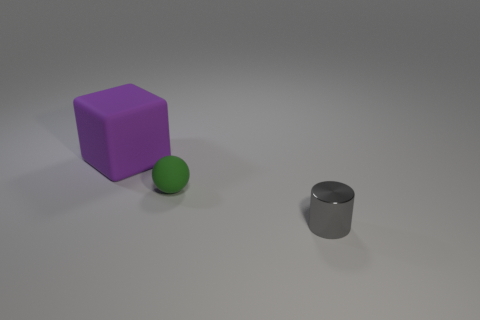Are the object that is left of the matte sphere and the tiny object that is left of the gray cylinder made of the same material?
Your answer should be compact. Yes. How many large objects have the same shape as the small gray object?
Offer a terse response. 0. Are there more big purple matte cubes to the right of the purple block than small red metallic spheres?
Give a very brief answer. No. What is the shape of the tiny object that is behind the thing that is on the right side of the tiny thing that is behind the tiny shiny cylinder?
Make the answer very short. Sphere. There is a small thing in front of the small green rubber ball; is its shape the same as the matte object in front of the large block?
Give a very brief answer. No. Is there any other thing that is the same size as the gray metallic cylinder?
Provide a short and direct response. Yes. What number of blocks are either tiny objects or small metal objects?
Your answer should be compact. 0. Is the tiny cylinder made of the same material as the block?
Ensure brevity in your answer.  No. There is a tiny object that is to the left of the small cylinder; what is its shape?
Offer a terse response. Sphere. What number of objects are small green objects or small shiny cylinders?
Ensure brevity in your answer.  2. 